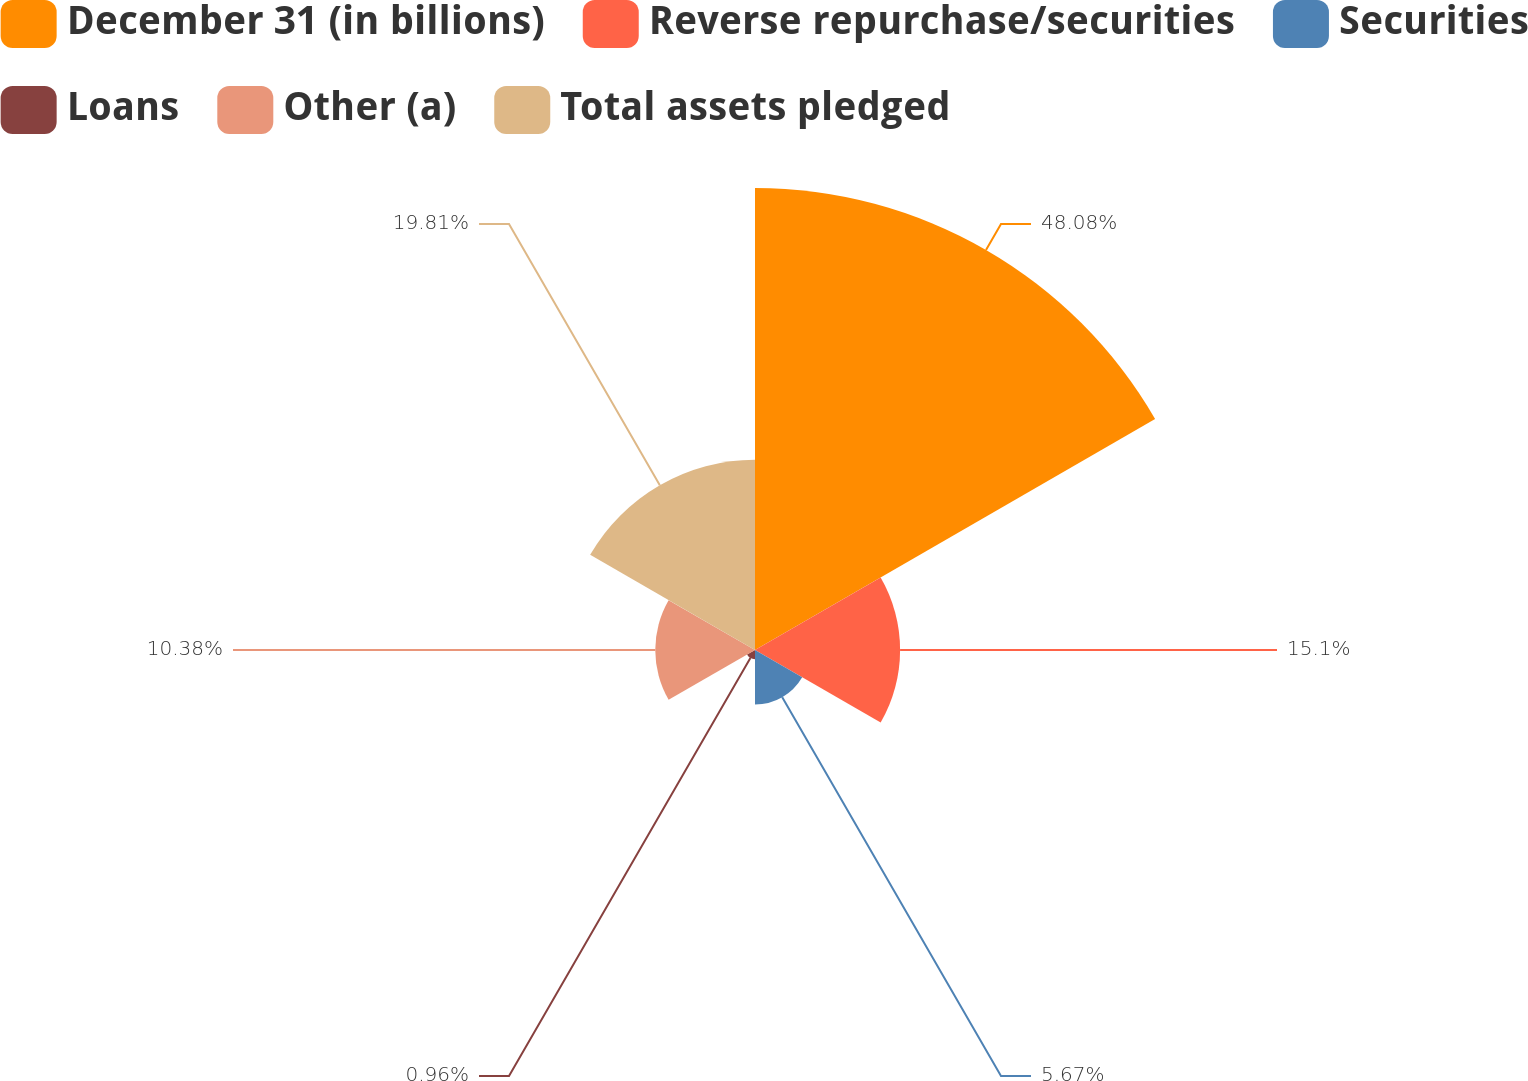Convert chart to OTSL. <chart><loc_0><loc_0><loc_500><loc_500><pie_chart><fcel>December 31 (in billions)<fcel>Reverse repurchase/securities<fcel>Securities<fcel>Loans<fcel>Other (a)<fcel>Total assets pledged<nl><fcel>48.08%<fcel>15.1%<fcel>5.67%<fcel>0.96%<fcel>10.38%<fcel>19.81%<nl></chart> 